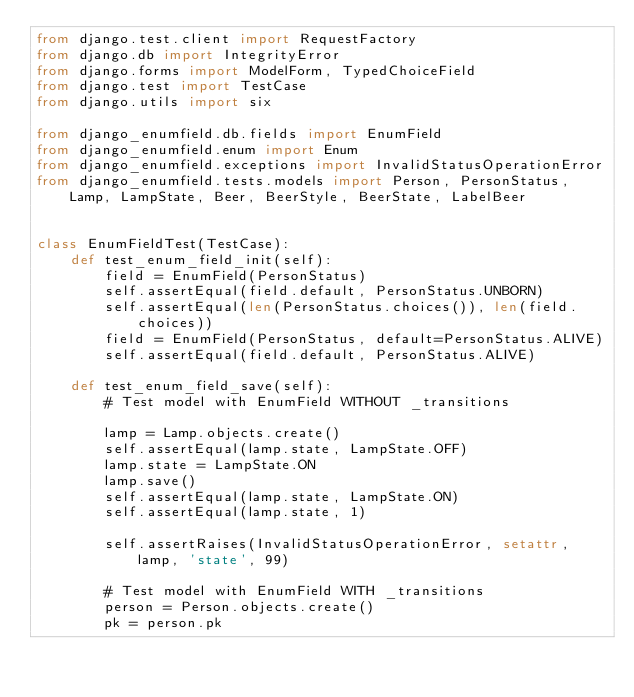Convert code to text. <code><loc_0><loc_0><loc_500><loc_500><_Python_>from django.test.client import RequestFactory
from django.db import IntegrityError
from django.forms import ModelForm, TypedChoiceField
from django.test import TestCase
from django.utils import six

from django_enumfield.db.fields import EnumField
from django_enumfield.enum import Enum
from django_enumfield.exceptions import InvalidStatusOperationError
from django_enumfield.tests.models import Person, PersonStatus, Lamp, LampState, Beer, BeerStyle, BeerState, LabelBeer


class EnumFieldTest(TestCase):
    def test_enum_field_init(self):
        field = EnumField(PersonStatus)
        self.assertEqual(field.default, PersonStatus.UNBORN)
        self.assertEqual(len(PersonStatus.choices()), len(field.choices))
        field = EnumField(PersonStatus, default=PersonStatus.ALIVE)
        self.assertEqual(field.default, PersonStatus.ALIVE)

    def test_enum_field_save(self):
        # Test model with EnumField WITHOUT _transitions

        lamp = Lamp.objects.create()
        self.assertEqual(lamp.state, LampState.OFF)
        lamp.state = LampState.ON
        lamp.save()
        self.assertEqual(lamp.state, LampState.ON)
        self.assertEqual(lamp.state, 1)

        self.assertRaises(InvalidStatusOperationError, setattr, lamp, 'state', 99)

        # Test model with EnumField WITH _transitions
        person = Person.objects.create()
        pk = person.pk</code> 